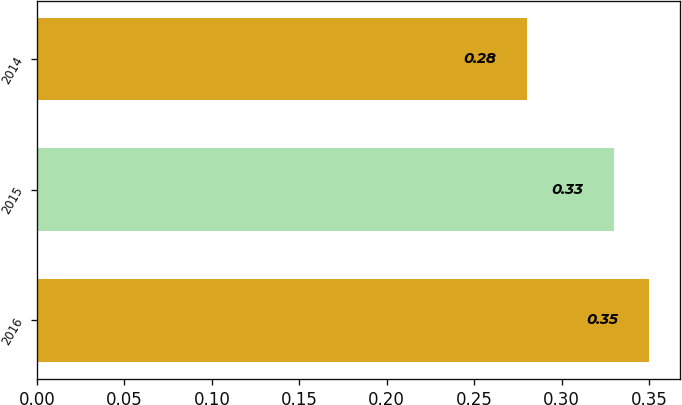<chart> <loc_0><loc_0><loc_500><loc_500><bar_chart><fcel>2016<fcel>2015<fcel>2014<nl><fcel>0.35<fcel>0.33<fcel>0.28<nl></chart> 